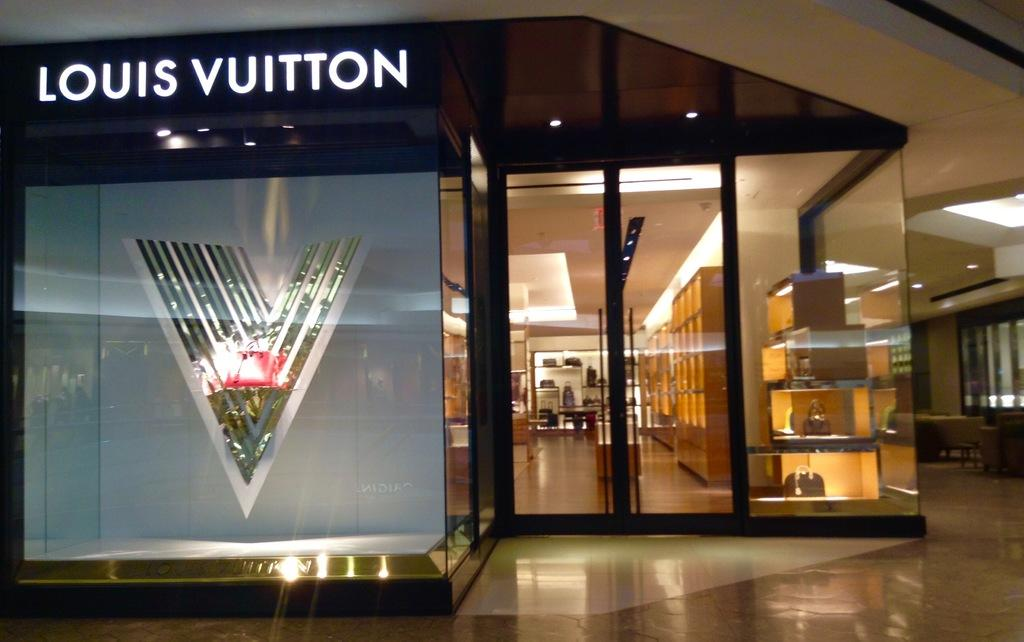<image>
Share a concise interpretation of the image provided. The lights are on inside a Louis Vuitton store with no people visible. 